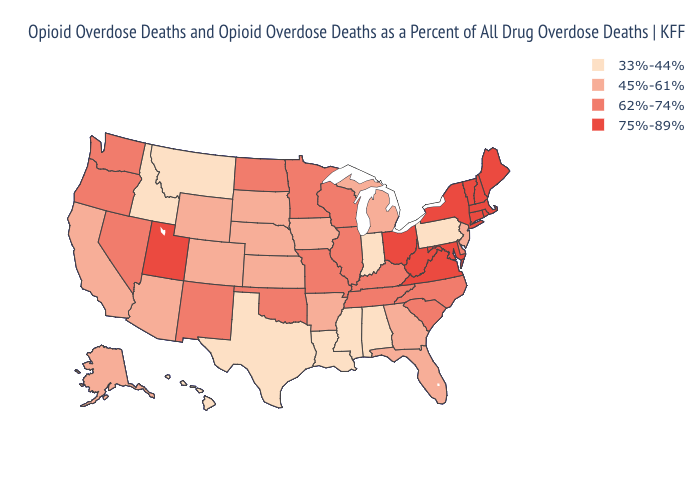Among the states that border Missouri , which have the highest value?
Be succinct. Illinois, Kentucky, Oklahoma, Tennessee. Name the states that have a value in the range 45%-61%?
Answer briefly. Alaska, Arizona, Arkansas, California, Colorado, Florida, Georgia, Iowa, Kansas, Michigan, Nebraska, New Jersey, South Dakota, Wyoming. Does Florida have the same value as Mississippi?
Give a very brief answer. No. What is the value of Iowa?
Quick response, please. 45%-61%. What is the value of West Virginia?
Short answer required. 75%-89%. What is the value of Idaho?
Keep it brief. 33%-44%. Does Texas have a lower value than Montana?
Quick response, please. No. Does the first symbol in the legend represent the smallest category?
Answer briefly. Yes. What is the lowest value in states that border Illinois?
Concise answer only. 33%-44%. What is the highest value in the South ?
Give a very brief answer. 75%-89%. Which states have the lowest value in the USA?
Be succinct. Alabama, Hawaii, Idaho, Indiana, Louisiana, Mississippi, Montana, Pennsylvania, Texas. Name the states that have a value in the range 75%-89%?
Keep it brief. Connecticut, Maine, Maryland, Massachusetts, New Hampshire, New York, Ohio, Rhode Island, Utah, Vermont, Virginia, West Virginia. What is the value of Nevada?
Give a very brief answer. 62%-74%. What is the value of Kentucky?
Short answer required. 62%-74%. Which states have the lowest value in the USA?
Concise answer only. Alabama, Hawaii, Idaho, Indiana, Louisiana, Mississippi, Montana, Pennsylvania, Texas. 